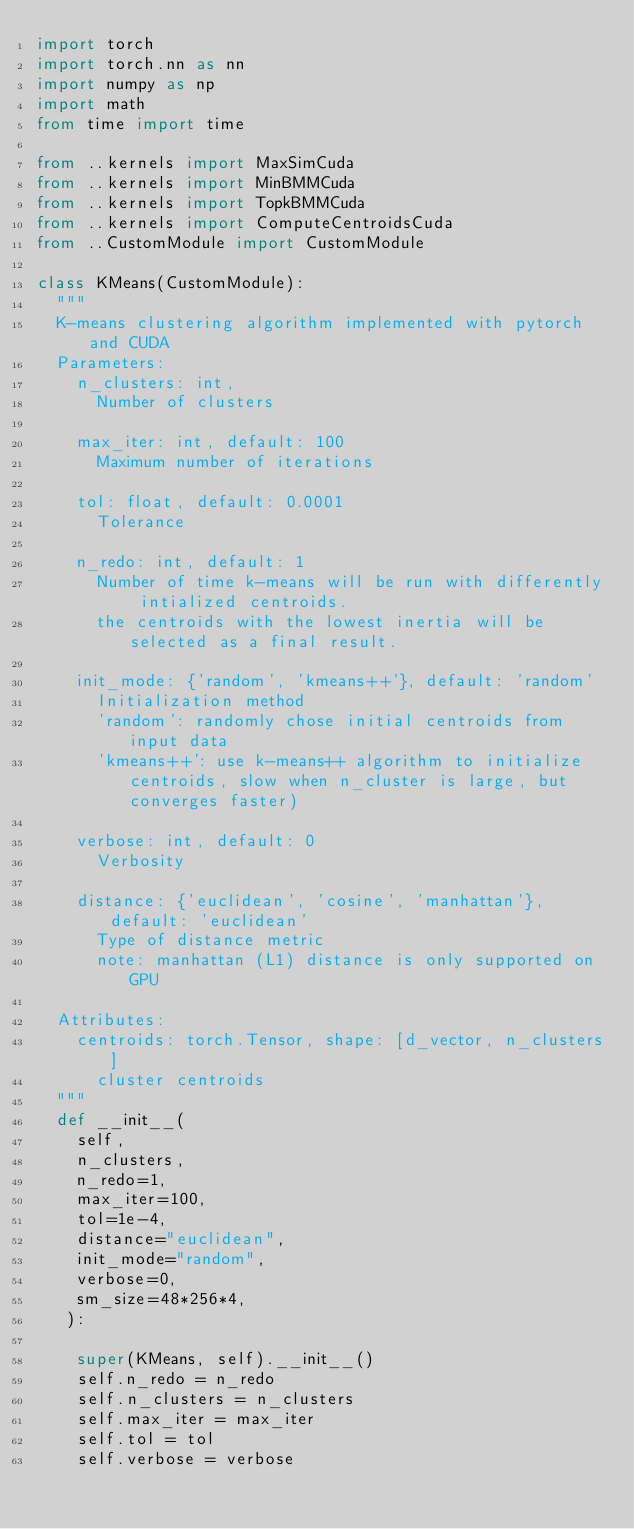Convert code to text. <code><loc_0><loc_0><loc_500><loc_500><_Python_>import torch
import torch.nn as nn
import numpy as np
import math
from time import time

from ..kernels import MaxSimCuda
from ..kernels import MinBMMCuda
from ..kernels import TopkBMMCuda
from ..kernels import ComputeCentroidsCuda
from ..CustomModule import CustomModule

class KMeans(CustomModule):
  """
  K-means clustering algorithm implemented with pytorch and CUDA
  Parameters:
    n_clusters: int, 
      Number of clusters

    max_iter: int, default: 100
      Maximum number of iterations

    tol: float, default: 0.0001
      Tolerance

    n_redo: int, default: 1
      Number of time k-means will be run with differently intialized centroids.
      the centroids with the lowest inertia will be selected as a final result.

    init_mode: {'random', 'kmeans++'}, default: 'random'
      Initialization method
      'random': randomly chose initial centroids from input data
      'kmeans++': use k-means++ algorithm to initialize centroids, slow when n_cluster is large, but converges faster)
    
    verbose: int, default: 0
      Verbosity

    distance: {'euclidean', 'cosine', 'manhattan'}, default: 'euclidean'
      Type of distance metric
      note: manhattan (L1) distance is only supported on GPU
      
  Attributes:
    centroids: torch.Tensor, shape: [d_vector, n_clusters]
      cluster centroids
  """
  def __init__(
    self,
    n_clusters,
    n_redo=1,
    max_iter=100,
    tol=1e-4,
    distance="euclidean",
    init_mode="random",
    verbose=0,
    sm_size=48*256*4,
   ):
  
    super(KMeans, self).__init__()
    self.n_redo = n_redo
    self.n_clusters = n_clusters
    self.max_iter = max_iter
    self.tol = tol
    self.verbose = verbose</code> 